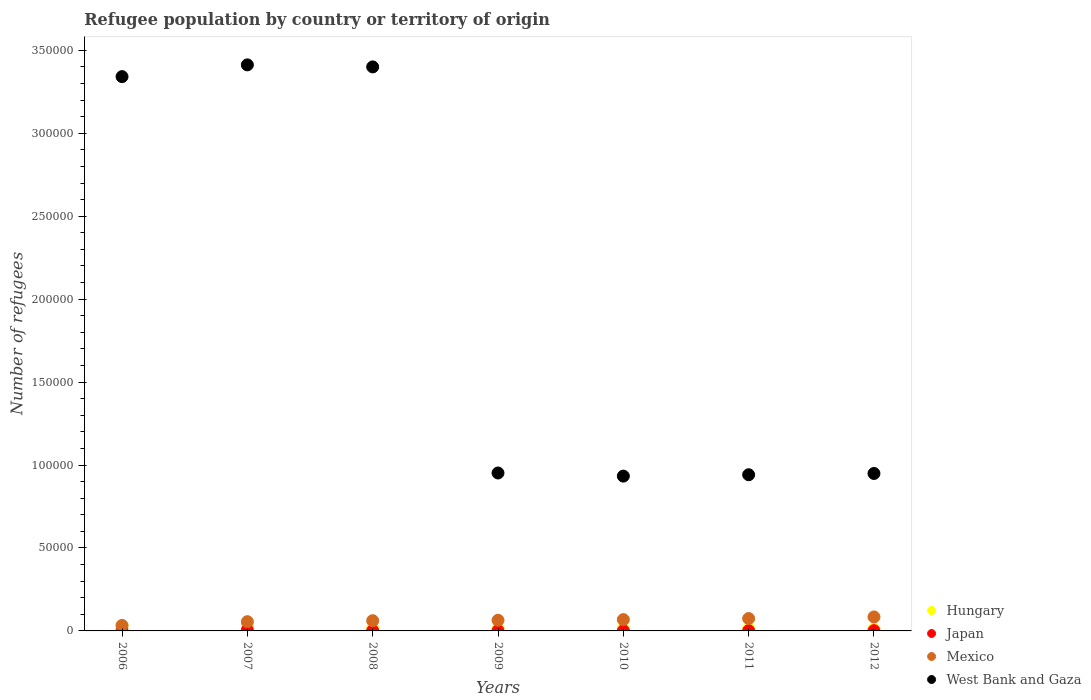How many different coloured dotlines are there?
Your answer should be compact. 4. What is the number of refugees in Japan in 2006?
Provide a short and direct response. 168. Across all years, what is the maximum number of refugees in Hungary?
Give a very brief answer. 3386. Across all years, what is the minimum number of refugees in Hungary?
Keep it short and to the point. 1087. In which year was the number of refugees in Hungary maximum?
Your answer should be compact. 2007. What is the total number of refugees in Hungary in the graph?
Ensure brevity in your answer.  1.34e+04. What is the difference between the number of refugees in West Bank and Gaza in 2007 and that in 2011?
Your answer should be compact. 2.47e+05. What is the difference between the number of refugees in West Bank and Gaza in 2008 and the number of refugees in Japan in 2009?
Your response must be concise. 3.40e+05. What is the average number of refugees in Mexico per year?
Provide a short and direct response. 6313.71. In the year 2009, what is the difference between the number of refugees in Japan and number of refugees in Hungary?
Provide a short and direct response. -1387. What is the ratio of the number of refugees in Mexico in 2009 to that in 2011?
Give a very brief answer. 0.86. Is the number of refugees in Hungary in 2006 less than that in 2009?
Make the answer very short. No. Is the difference between the number of refugees in Japan in 2007 and 2011 greater than the difference between the number of refugees in Hungary in 2007 and 2011?
Provide a short and direct response. No. What is the difference between the highest and the second highest number of refugees in Hungary?
Make the answer very short. 268. What is the difference between the highest and the lowest number of refugees in Japan?
Keep it short and to the point. 371. In how many years, is the number of refugees in Japan greater than the average number of refugees in Japan taken over all years?
Ensure brevity in your answer.  1. Is it the case that in every year, the sum of the number of refugees in Mexico and number of refugees in Japan  is greater than the sum of number of refugees in Hungary and number of refugees in West Bank and Gaza?
Ensure brevity in your answer.  No. Does the number of refugees in West Bank and Gaza monotonically increase over the years?
Provide a succinct answer. No. Is the number of refugees in Hungary strictly greater than the number of refugees in Mexico over the years?
Your answer should be compact. No. How many years are there in the graph?
Your answer should be very brief. 7. What is the difference between two consecutive major ticks on the Y-axis?
Offer a terse response. 5.00e+04. Are the values on the major ticks of Y-axis written in scientific E-notation?
Your answer should be very brief. No. Does the graph contain grids?
Keep it short and to the point. No. Where does the legend appear in the graph?
Offer a very short reply. Bottom right. How many legend labels are there?
Your answer should be very brief. 4. How are the legend labels stacked?
Keep it short and to the point. Vertical. What is the title of the graph?
Your response must be concise. Refugee population by country or territory of origin. Does "Nigeria" appear as one of the legend labels in the graph?
Keep it short and to the point. No. What is the label or title of the X-axis?
Your response must be concise. Years. What is the label or title of the Y-axis?
Offer a terse response. Number of refugees. What is the Number of refugees of Hungary in 2006?
Your response must be concise. 3118. What is the Number of refugees of Japan in 2006?
Your response must be concise. 168. What is the Number of refugees in Mexico in 2006?
Ensure brevity in your answer.  3304. What is the Number of refugees of West Bank and Gaza in 2006?
Your answer should be compact. 3.34e+05. What is the Number of refugees in Hungary in 2007?
Keep it short and to the point. 3386. What is the Number of refugees in Japan in 2007?
Ensure brevity in your answer.  521. What is the Number of refugees of Mexico in 2007?
Offer a very short reply. 5572. What is the Number of refugees of West Bank and Gaza in 2007?
Provide a succinct answer. 3.41e+05. What is the Number of refugees of Hungary in 2008?
Offer a very short reply. 1614. What is the Number of refugees of Japan in 2008?
Your response must be concise. 185. What is the Number of refugees in Mexico in 2008?
Provide a short and direct response. 6162. What is the Number of refugees in West Bank and Gaza in 2008?
Provide a short and direct response. 3.40e+05. What is the Number of refugees of Hungary in 2009?
Your answer should be compact. 1537. What is the Number of refugees of Japan in 2009?
Keep it short and to the point. 150. What is the Number of refugees in Mexico in 2009?
Your answer should be very brief. 6435. What is the Number of refugees in West Bank and Gaza in 2009?
Make the answer very short. 9.52e+04. What is the Number of refugees in Hungary in 2010?
Give a very brief answer. 1438. What is the Number of refugees in Japan in 2010?
Your answer should be compact. 152. What is the Number of refugees in Mexico in 2010?
Provide a short and direct response. 6816. What is the Number of refugees in West Bank and Gaza in 2010?
Ensure brevity in your answer.  9.33e+04. What is the Number of refugees in Hungary in 2011?
Give a very brief answer. 1238. What is the Number of refugees of Japan in 2011?
Ensure brevity in your answer.  176. What is the Number of refugees of Mexico in 2011?
Make the answer very short. 7472. What is the Number of refugees in West Bank and Gaza in 2011?
Your response must be concise. 9.42e+04. What is the Number of refugees of Hungary in 2012?
Your answer should be very brief. 1087. What is the Number of refugees in Japan in 2012?
Your response must be concise. 172. What is the Number of refugees in Mexico in 2012?
Offer a very short reply. 8435. What is the Number of refugees in West Bank and Gaza in 2012?
Your answer should be very brief. 9.49e+04. Across all years, what is the maximum Number of refugees in Hungary?
Give a very brief answer. 3386. Across all years, what is the maximum Number of refugees in Japan?
Offer a very short reply. 521. Across all years, what is the maximum Number of refugees in Mexico?
Provide a short and direct response. 8435. Across all years, what is the maximum Number of refugees in West Bank and Gaza?
Offer a very short reply. 3.41e+05. Across all years, what is the minimum Number of refugees in Hungary?
Your response must be concise. 1087. Across all years, what is the minimum Number of refugees in Japan?
Provide a succinct answer. 150. Across all years, what is the minimum Number of refugees of Mexico?
Offer a very short reply. 3304. Across all years, what is the minimum Number of refugees of West Bank and Gaza?
Provide a short and direct response. 9.33e+04. What is the total Number of refugees of Hungary in the graph?
Make the answer very short. 1.34e+04. What is the total Number of refugees of Japan in the graph?
Offer a terse response. 1524. What is the total Number of refugees in Mexico in the graph?
Give a very brief answer. 4.42e+04. What is the total Number of refugees in West Bank and Gaza in the graph?
Give a very brief answer. 1.39e+06. What is the difference between the Number of refugees of Hungary in 2006 and that in 2007?
Your response must be concise. -268. What is the difference between the Number of refugees of Japan in 2006 and that in 2007?
Keep it short and to the point. -353. What is the difference between the Number of refugees in Mexico in 2006 and that in 2007?
Your answer should be very brief. -2268. What is the difference between the Number of refugees in West Bank and Gaza in 2006 and that in 2007?
Provide a short and direct response. -7095. What is the difference between the Number of refugees in Hungary in 2006 and that in 2008?
Give a very brief answer. 1504. What is the difference between the Number of refugees of Mexico in 2006 and that in 2008?
Keep it short and to the point. -2858. What is the difference between the Number of refugees in West Bank and Gaza in 2006 and that in 2008?
Your answer should be very brief. -5874. What is the difference between the Number of refugees of Hungary in 2006 and that in 2009?
Provide a succinct answer. 1581. What is the difference between the Number of refugees of Mexico in 2006 and that in 2009?
Your response must be concise. -3131. What is the difference between the Number of refugees in West Bank and Gaza in 2006 and that in 2009?
Your answer should be very brief. 2.39e+05. What is the difference between the Number of refugees of Hungary in 2006 and that in 2010?
Make the answer very short. 1680. What is the difference between the Number of refugees of Mexico in 2006 and that in 2010?
Ensure brevity in your answer.  -3512. What is the difference between the Number of refugees of West Bank and Gaza in 2006 and that in 2010?
Make the answer very short. 2.41e+05. What is the difference between the Number of refugees in Hungary in 2006 and that in 2011?
Ensure brevity in your answer.  1880. What is the difference between the Number of refugees of Japan in 2006 and that in 2011?
Your answer should be compact. -8. What is the difference between the Number of refugees of Mexico in 2006 and that in 2011?
Your answer should be compact. -4168. What is the difference between the Number of refugees in West Bank and Gaza in 2006 and that in 2011?
Provide a short and direct response. 2.40e+05. What is the difference between the Number of refugees in Hungary in 2006 and that in 2012?
Provide a short and direct response. 2031. What is the difference between the Number of refugees in Japan in 2006 and that in 2012?
Your response must be concise. -4. What is the difference between the Number of refugees in Mexico in 2006 and that in 2012?
Ensure brevity in your answer.  -5131. What is the difference between the Number of refugees in West Bank and Gaza in 2006 and that in 2012?
Give a very brief answer. 2.39e+05. What is the difference between the Number of refugees of Hungary in 2007 and that in 2008?
Your answer should be very brief. 1772. What is the difference between the Number of refugees in Japan in 2007 and that in 2008?
Offer a very short reply. 336. What is the difference between the Number of refugees in Mexico in 2007 and that in 2008?
Your answer should be compact. -590. What is the difference between the Number of refugees in West Bank and Gaza in 2007 and that in 2008?
Make the answer very short. 1221. What is the difference between the Number of refugees in Hungary in 2007 and that in 2009?
Provide a short and direct response. 1849. What is the difference between the Number of refugees of Japan in 2007 and that in 2009?
Your answer should be very brief. 371. What is the difference between the Number of refugees of Mexico in 2007 and that in 2009?
Your answer should be very brief. -863. What is the difference between the Number of refugees in West Bank and Gaza in 2007 and that in 2009?
Provide a short and direct response. 2.46e+05. What is the difference between the Number of refugees in Hungary in 2007 and that in 2010?
Keep it short and to the point. 1948. What is the difference between the Number of refugees of Japan in 2007 and that in 2010?
Provide a succinct answer. 369. What is the difference between the Number of refugees in Mexico in 2007 and that in 2010?
Ensure brevity in your answer.  -1244. What is the difference between the Number of refugees of West Bank and Gaza in 2007 and that in 2010?
Your answer should be compact. 2.48e+05. What is the difference between the Number of refugees in Hungary in 2007 and that in 2011?
Provide a short and direct response. 2148. What is the difference between the Number of refugees in Japan in 2007 and that in 2011?
Provide a succinct answer. 345. What is the difference between the Number of refugees of Mexico in 2007 and that in 2011?
Your answer should be very brief. -1900. What is the difference between the Number of refugees in West Bank and Gaza in 2007 and that in 2011?
Provide a succinct answer. 2.47e+05. What is the difference between the Number of refugees of Hungary in 2007 and that in 2012?
Your response must be concise. 2299. What is the difference between the Number of refugees of Japan in 2007 and that in 2012?
Ensure brevity in your answer.  349. What is the difference between the Number of refugees of Mexico in 2007 and that in 2012?
Offer a terse response. -2863. What is the difference between the Number of refugees in West Bank and Gaza in 2007 and that in 2012?
Your answer should be compact. 2.46e+05. What is the difference between the Number of refugees of Hungary in 2008 and that in 2009?
Provide a succinct answer. 77. What is the difference between the Number of refugees in Japan in 2008 and that in 2009?
Offer a terse response. 35. What is the difference between the Number of refugees of Mexico in 2008 and that in 2009?
Provide a succinct answer. -273. What is the difference between the Number of refugees of West Bank and Gaza in 2008 and that in 2009?
Make the answer very short. 2.45e+05. What is the difference between the Number of refugees of Hungary in 2008 and that in 2010?
Provide a succinct answer. 176. What is the difference between the Number of refugees in Japan in 2008 and that in 2010?
Your answer should be compact. 33. What is the difference between the Number of refugees in Mexico in 2008 and that in 2010?
Make the answer very short. -654. What is the difference between the Number of refugees in West Bank and Gaza in 2008 and that in 2010?
Ensure brevity in your answer.  2.47e+05. What is the difference between the Number of refugees of Hungary in 2008 and that in 2011?
Provide a short and direct response. 376. What is the difference between the Number of refugees of Mexico in 2008 and that in 2011?
Provide a succinct answer. -1310. What is the difference between the Number of refugees in West Bank and Gaza in 2008 and that in 2011?
Give a very brief answer. 2.46e+05. What is the difference between the Number of refugees in Hungary in 2008 and that in 2012?
Keep it short and to the point. 527. What is the difference between the Number of refugees in Japan in 2008 and that in 2012?
Keep it short and to the point. 13. What is the difference between the Number of refugees in Mexico in 2008 and that in 2012?
Make the answer very short. -2273. What is the difference between the Number of refugees in West Bank and Gaza in 2008 and that in 2012?
Your answer should be very brief. 2.45e+05. What is the difference between the Number of refugees in Hungary in 2009 and that in 2010?
Your response must be concise. 99. What is the difference between the Number of refugees in Mexico in 2009 and that in 2010?
Your response must be concise. -381. What is the difference between the Number of refugees of West Bank and Gaza in 2009 and that in 2010?
Make the answer very short. 1878. What is the difference between the Number of refugees in Hungary in 2009 and that in 2011?
Keep it short and to the point. 299. What is the difference between the Number of refugees in Mexico in 2009 and that in 2011?
Offer a terse response. -1037. What is the difference between the Number of refugees in West Bank and Gaza in 2009 and that in 2011?
Give a very brief answer. 1051. What is the difference between the Number of refugees of Hungary in 2009 and that in 2012?
Provide a succinct answer. 450. What is the difference between the Number of refugees in Japan in 2009 and that in 2012?
Your answer should be compact. -22. What is the difference between the Number of refugees in Mexico in 2009 and that in 2012?
Provide a short and direct response. -2000. What is the difference between the Number of refugees of West Bank and Gaza in 2009 and that in 2012?
Provide a succinct answer. 283. What is the difference between the Number of refugees of Mexico in 2010 and that in 2011?
Make the answer very short. -656. What is the difference between the Number of refugees in West Bank and Gaza in 2010 and that in 2011?
Give a very brief answer. -827. What is the difference between the Number of refugees of Hungary in 2010 and that in 2012?
Offer a very short reply. 351. What is the difference between the Number of refugees of Mexico in 2010 and that in 2012?
Your response must be concise. -1619. What is the difference between the Number of refugees of West Bank and Gaza in 2010 and that in 2012?
Offer a very short reply. -1595. What is the difference between the Number of refugees of Hungary in 2011 and that in 2012?
Keep it short and to the point. 151. What is the difference between the Number of refugees in Japan in 2011 and that in 2012?
Offer a very short reply. 4. What is the difference between the Number of refugees in Mexico in 2011 and that in 2012?
Keep it short and to the point. -963. What is the difference between the Number of refugees of West Bank and Gaza in 2011 and that in 2012?
Your answer should be very brief. -768. What is the difference between the Number of refugees of Hungary in 2006 and the Number of refugees of Japan in 2007?
Your answer should be very brief. 2597. What is the difference between the Number of refugees in Hungary in 2006 and the Number of refugees in Mexico in 2007?
Make the answer very short. -2454. What is the difference between the Number of refugees in Hungary in 2006 and the Number of refugees in West Bank and Gaza in 2007?
Offer a very short reply. -3.38e+05. What is the difference between the Number of refugees in Japan in 2006 and the Number of refugees in Mexico in 2007?
Provide a succinct answer. -5404. What is the difference between the Number of refugees in Japan in 2006 and the Number of refugees in West Bank and Gaza in 2007?
Your answer should be compact. -3.41e+05. What is the difference between the Number of refugees of Mexico in 2006 and the Number of refugees of West Bank and Gaza in 2007?
Provide a succinct answer. -3.38e+05. What is the difference between the Number of refugees in Hungary in 2006 and the Number of refugees in Japan in 2008?
Provide a short and direct response. 2933. What is the difference between the Number of refugees of Hungary in 2006 and the Number of refugees of Mexico in 2008?
Your response must be concise. -3044. What is the difference between the Number of refugees of Hungary in 2006 and the Number of refugees of West Bank and Gaza in 2008?
Ensure brevity in your answer.  -3.37e+05. What is the difference between the Number of refugees of Japan in 2006 and the Number of refugees of Mexico in 2008?
Ensure brevity in your answer.  -5994. What is the difference between the Number of refugees in Japan in 2006 and the Number of refugees in West Bank and Gaza in 2008?
Your answer should be very brief. -3.40e+05. What is the difference between the Number of refugees of Mexico in 2006 and the Number of refugees of West Bank and Gaza in 2008?
Offer a very short reply. -3.37e+05. What is the difference between the Number of refugees in Hungary in 2006 and the Number of refugees in Japan in 2009?
Offer a terse response. 2968. What is the difference between the Number of refugees of Hungary in 2006 and the Number of refugees of Mexico in 2009?
Offer a very short reply. -3317. What is the difference between the Number of refugees of Hungary in 2006 and the Number of refugees of West Bank and Gaza in 2009?
Offer a very short reply. -9.21e+04. What is the difference between the Number of refugees of Japan in 2006 and the Number of refugees of Mexico in 2009?
Your response must be concise. -6267. What is the difference between the Number of refugees in Japan in 2006 and the Number of refugees in West Bank and Gaza in 2009?
Offer a very short reply. -9.50e+04. What is the difference between the Number of refugees of Mexico in 2006 and the Number of refugees of West Bank and Gaza in 2009?
Make the answer very short. -9.19e+04. What is the difference between the Number of refugees of Hungary in 2006 and the Number of refugees of Japan in 2010?
Ensure brevity in your answer.  2966. What is the difference between the Number of refugees in Hungary in 2006 and the Number of refugees in Mexico in 2010?
Keep it short and to the point. -3698. What is the difference between the Number of refugees in Hungary in 2006 and the Number of refugees in West Bank and Gaza in 2010?
Provide a succinct answer. -9.02e+04. What is the difference between the Number of refugees in Japan in 2006 and the Number of refugees in Mexico in 2010?
Your answer should be compact. -6648. What is the difference between the Number of refugees of Japan in 2006 and the Number of refugees of West Bank and Gaza in 2010?
Give a very brief answer. -9.32e+04. What is the difference between the Number of refugees of Mexico in 2006 and the Number of refugees of West Bank and Gaza in 2010?
Provide a short and direct response. -9.00e+04. What is the difference between the Number of refugees in Hungary in 2006 and the Number of refugees in Japan in 2011?
Ensure brevity in your answer.  2942. What is the difference between the Number of refugees of Hungary in 2006 and the Number of refugees of Mexico in 2011?
Ensure brevity in your answer.  -4354. What is the difference between the Number of refugees of Hungary in 2006 and the Number of refugees of West Bank and Gaza in 2011?
Ensure brevity in your answer.  -9.10e+04. What is the difference between the Number of refugees of Japan in 2006 and the Number of refugees of Mexico in 2011?
Offer a terse response. -7304. What is the difference between the Number of refugees in Japan in 2006 and the Number of refugees in West Bank and Gaza in 2011?
Keep it short and to the point. -9.40e+04. What is the difference between the Number of refugees in Mexico in 2006 and the Number of refugees in West Bank and Gaza in 2011?
Provide a succinct answer. -9.08e+04. What is the difference between the Number of refugees of Hungary in 2006 and the Number of refugees of Japan in 2012?
Your response must be concise. 2946. What is the difference between the Number of refugees of Hungary in 2006 and the Number of refugees of Mexico in 2012?
Ensure brevity in your answer.  -5317. What is the difference between the Number of refugees in Hungary in 2006 and the Number of refugees in West Bank and Gaza in 2012?
Make the answer very short. -9.18e+04. What is the difference between the Number of refugees of Japan in 2006 and the Number of refugees of Mexico in 2012?
Provide a short and direct response. -8267. What is the difference between the Number of refugees in Japan in 2006 and the Number of refugees in West Bank and Gaza in 2012?
Ensure brevity in your answer.  -9.48e+04. What is the difference between the Number of refugees in Mexico in 2006 and the Number of refugees in West Bank and Gaza in 2012?
Offer a terse response. -9.16e+04. What is the difference between the Number of refugees of Hungary in 2007 and the Number of refugees of Japan in 2008?
Make the answer very short. 3201. What is the difference between the Number of refugees of Hungary in 2007 and the Number of refugees of Mexico in 2008?
Make the answer very short. -2776. What is the difference between the Number of refugees of Hungary in 2007 and the Number of refugees of West Bank and Gaza in 2008?
Keep it short and to the point. -3.37e+05. What is the difference between the Number of refugees in Japan in 2007 and the Number of refugees in Mexico in 2008?
Your answer should be very brief. -5641. What is the difference between the Number of refugees in Japan in 2007 and the Number of refugees in West Bank and Gaza in 2008?
Your answer should be compact. -3.39e+05. What is the difference between the Number of refugees of Mexico in 2007 and the Number of refugees of West Bank and Gaza in 2008?
Ensure brevity in your answer.  -3.34e+05. What is the difference between the Number of refugees of Hungary in 2007 and the Number of refugees of Japan in 2009?
Provide a short and direct response. 3236. What is the difference between the Number of refugees in Hungary in 2007 and the Number of refugees in Mexico in 2009?
Give a very brief answer. -3049. What is the difference between the Number of refugees in Hungary in 2007 and the Number of refugees in West Bank and Gaza in 2009?
Make the answer very short. -9.18e+04. What is the difference between the Number of refugees of Japan in 2007 and the Number of refugees of Mexico in 2009?
Make the answer very short. -5914. What is the difference between the Number of refugees in Japan in 2007 and the Number of refugees in West Bank and Gaza in 2009?
Your answer should be very brief. -9.47e+04. What is the difference between the Number of refugees of Mexico in 2007 and the Number of refugees of West Bank and Gaza in 2009?
Keep it short and to the point. -8.96e+04. What is the difference between the Number of refugees in Hungary in 2007 and the Number of refugees in Japan in 2010?
Give a very brief answer. 3234. What is the difference between the Number of refugees in Hungary in 2007 and the Number of refugees in Mexico in 2010?
Your answer should be very brief. -3430. What is the difference between the Number of refugees of Hungary in 2007 and the Number of refugees of West Bank and Gaza in 2010?
Give a very brief answer. -8.99e+04. What is the difference between the Number of refugees of Japan in 2007 and the Number of refugees of Mexico in 2010?
Your answer should be compact. -6295. What is the difference between the Number of refugees of Japan in 2007 and the Number of refugees of West Bank and Gaza in 2010?
Give a very brief answer. -9.28e+04. What is the difference between the Number of refugees of Mexico in 2007 and the Number of refugees of West Bank and Gaza in 2010?
Make the answer very short. -8.78e+04. What is the difference between the Number of refugees of Hungary in 2007 and the Number of refugees of Japan in 2011?
Provide a short and direct response. 3210. What is the difference between the Number of refugees in Hungary in 2007 and the Number of refugees in Mexico in 2011?
Provide a short and direct response. -4086. What is the difference between the Number of refugees of Hungary in 2007 and the Number of refugees of West Bank and Gaza in 2011?
Ensure brevity in your answer.  -9.08e+04. What is the difference between the Number of refugees of Japan in 2007 and the Number of refugees of Mexico in 2011?
Your response must be concise. -6951. What is the difference between the Number of refugees in Japan in 2007 and the Number of refugees in West Bank and Gaza in 2011?
Offer a terse response. -9.36e+04. What is the difference between the Number of refugees in Mexico in 2007 and the Number of refugees in West Bank and Gaza in 2011?
Your response must be concise. -8.86e+04. What is the difference between the Number of refugees of Hungary in 2007 and the Number of refugees of Japan in 2012?
Offer a terse response. 3214. What is the difference between the Number of refugees in Hungary in 2007 and the Number of refugees in Mexico in 2012?
Your answer should be very brief. -5049. What is the difference between the Number of refugees of Hungary in 2007 and the Number of refugees of West Bank and Gaza in 2012?
Offer a very short reply. -9.15e+04. What is the difference between the Number of refugees of Japan in 2007 and the Number of refugees of Mexico in 2012?
Provide a succinct answer. -7914. What is the difference between the Number of refugees of Japan in 2007 and the Number of refugees of West Bank and Gaza in 2012?
Your response must be concise. -9.44e+04. What is the difference between the Number of refugees in Mexico in 2007 and the Number of refugees in West Bank and Gaza in 2012?
Your answer should be very brief. -8.93e+04. What is the difference between the Number of refugees in Hungary in 2008 and the Number of refugees in Japan in 2009?
Your answer should be compact. 1464. What is the difference between the Number of refugees in Hungary in 2008 and the Number of refugees in Mexico in 2009?
Your response must be concise. -4821. What is the difference between the Number of refugees of Hungary in 2008 and the Number of refugees of West Bank and Gaza in 2009?
Your response must be concise. -9.36e+04. What is the difference between the Number of refugees of Japan in 2008 and the Number of refugees of Mexico in 2009?
Provide a short and direct response. -6250. What is the difference between the Number of refugees of Japan in 2008 and the Number of refugees of West Bank and Gaza in 2009?
Ensure brevity in your answer.  -9.50e+04. What is the difference between the Number of refugees in Mexico in 2008 and the Number of refugees in West Bank and Gaza in 2009?
Offer a very short reply. -8.90e+04. What is the difference between the Number of refugees of Hungary in 2008 and the Number of refugees of Japan in 2010?
Keep it short and to the point. 1462. What is the difference between the Number of refugees of Hungary in 2008 and the Number of refugees of Mexico in 2010?
Keep it short and to the point. -5202. What is the difference between the Number of refugees of Hungary in 2008 and the Number of refugees of West Bank and Gaza in 2010?
Offer a very short reply. -9.17e+04. What is the difference between the Number of refugees in Japan in 2008 and the Number of refugees in Mexico in 2010?
Ensure brevity in your answer.  -6631. What is the difference between the Number of refugees in Japan in 2008 and the Number of refugees in West Bank and Gaza in 2010?
Ensure brevity in your answer.  -9.31e+04. What is the difference between the Number of refugees of Mexico in 2008 and the Number of refugees of West Bank and Gaza in 2010?
Your answer should be compact. -8.72e+04. What is the difference between the Number of refugees in Hungary in 2008 and the Number of refugees in Japan in 2011?
Make the answer very short. 1438. What is the difference between the Number of refugees in Hungary in 2008 and the Number of refugees in Mexico in 2011?
Give a very brief answer. -5858. What is the difference between the Number of refugees in Hungary in 2008 and the Number of refugees in West Bank and Gaza in 2011?
Keep it short and to the point. -9.25e+04. What is the difference between the Number of refugees of Japan in 2008 and the Number of refugees of Mexico in 2011?
Your answer should be very brief. -7287. What is the difference between the Number of refugees of Japan in 2008 and the Number of refugees of West Bank and Gaza in 2011?
Give a very brief answer. -9.40e+04. What is the difference between the Number of refugees in Mexico in 2008 and the Number of refugees in West Bank and Gaza in 2011?
Offer a very short reply. -8.80e+04. What is the difference between the Number of refugees of Hungary in 2008 and the Number of refugees of Japan in 2012?
Your answer should be very brief. 1442. What is the difference between the Number of refugees of Hungary in 2008 and the Number of refugees of Mexico in 2012?
Provide a succinct answer. -6821. What is the difference between the Number of refugees in Hungary in 2008 and the Number of refugees in West Bank and Gaza in 2012?
Your answer should be compact. -9.33e+04. What is the difference between the Number of refugees in Japan in 2008 and the Number of refugees in Mexico in 2012?
Offer a very short reply. -8250. What is the difference between the Number of refugees in Japan in 2008 and the Number of refugees in West Bank and Gaza in 2012?
Keep it short and to the point. -9.47e+04. What is the difference between the Number of refugees of Mexico in 2008 and the Number of refugees of West Bank and Gaza in 2012?
Your response must be concise. -8.88e+04. What is the difference between the Number of refugees of Hungary in 2009 and the Number of refugees of Japan in 2010?
Give a very brief answer. 1385. What is the difference between the Number of refugees in Hungary in 2009 and the Number of refugees in Mexico in 2010?
Make the answer very short. -5279. What is the difference between the Number of refugees in Hungary in 2009 and the Number of refugees in West Bank and Gaza in 2010?
Offer a terse response. -9.18e+04. What is the difference between the Number of refugees of Japan in 2009 and the Number of refugees of Mexico in 2010?
Make the answer very short. -6666. What is the difference between the Number of refugees of Japan in 2009 and the Number of refugees of West Bank and Gaza in 2010?
Your response must be concise. -9.32e+04. What is the difference between the Number of refugees in Mexico in 2009 and the Number of refugees in West Bank and Gaza in 2010?
Your answer should be very brief. -8.69e+04. What is the difference between the Number of refugees in Hungary in 2009 and the Number of refugees in Japan in 2011?
Ensure brevity in your answer.  1361. What is the difference between the Number of refugees of Hungary in 2009 and the Number of refugees of Mexico in 2011?
Your answer should be compact. -5935. What is the difference between the Number of refugees of Hungary in 2009 and the Number of refugees of West Bank and Gaza in 2011?
Provide a short and direct response. -9.26e+04. What is the difference between the Number of refugees in Japan in 2009 and the Number of refugees in Mexico in 2011?
Provide a short and direct response. -7322. What is the difference between the Number of refugees of Japan in 2009 and the Number of refugees of West Bank and Gaza in 2011?
Your response must be concise. -9.40e+04. What is the difference between the Number of refugees in Mexico in 2009 and the Number of refugees in West Bank and Gaza in 2011?
Provide a succinct answer. -8.77e+04. What is the difference between the Number of refugees in Hungary in 2009 and the Number of refugees in Japan in 2012?
Ensure brevity in your answer.  1365. What is the difference between the Number of refugees of Hungary in 2009 and the Number of refugees of Mexico in 2012?
Ensure brevity in your answer.  -6898. What is the difference between the Number of refugees of Hungary in 2009 and the Number of refugees of West Bank and Gaza in 2012?
Offer a very short reply. -9.34e+04. What is the difference between the Number of refugees in Japan in 2009 and the Number of refugees in Mexico in 2012?
Give a very brief answer. -8285. What is the difference between the Number of refugees of Japan in 2009 and the Number of refugees of West Bank and Gaza in 2012?
Your answer should be compact. -9.48e+04. What is the difference between the Number of refugees of Mexico in 2009 and the Number of refugees of West Bank and Gaza in 2012?
Offer a very short reply. -8.85e+04. What is the difference between the Number of refugees in Hungary in 2010 and the Number of refugees in Japan in 2011?
Provide a short and direct response. 1262. What is the difference between the Number of refugees in Hungary in 2010 and the Number of refugees in Mexico in 2011?
Provide a short and direct response. -6034. What is the difference between the Number of refugees of Hungary in 2010 and the Number of refugees of West Bank and Gaza in 2011?
Your answer should be very brief. -9.27e+04. What is the difference between the Number of refugees of Japan in 2010 and the Number of refugees of Mexico in 2011?
Give a very brief answer. -7320. What is the difference between the Number of refugees in Japan in 2010 and the Number of refugees in West Bank and Gaza in 2011?
Offer a terse response. -9.40e+04. What is the difference between the Number of refugees in Mexico in 2010 and the Number of refugees in West Bank and Gaza in 2011?
Your answer should be compact. -8.73e+04. What is the difference between the Number of refugees in Hungary in 2010 and the Number of refugees in Japan in 2012?
Offer a terse response. 1266. What is the difference between the Number of refugees in Hungary in 2010 and the Number of refugees in Mexico in 2012?
Your answer should be compact. -6997. What is the difference between the Number of refugees of Hungary in 2010 and the Number of refugees of West Bank and Gaza in 2012?
Offer a very short reply. -9.35e+04. What is the difference between the Number of refugees of Japan in 2010 and the Number of refugees of Mexico in 2012?
Give a very brief answer. -8283. What is the difference between the Number of refugees of Japan in 2010 and the Number of refugees of West Bank and Gaza in 2012?
Your answer should be very brief. -9.48e+04. What is the difference between the Number of refugees of Mexico in 2010 and the Number of refugees of West Bank and Gaza in 2012?
Your answer should be compact. -8.81e+04. What is the difference between the Number of refugees in Hungary in 2011 and the Number of refugees in Japan in 2012?
Make the answer very short. 1066. What is the difference between the Number of refugees of Hungary in 2011 and the Number of refugees of Mexico in 2012?
Provide a succinct answer. -7197. What is the difference between the Number of refugees of Hungary in 2011 and the Number of refugees of West Bank and Gaza in 2012?
Offer a terse response. -9.37e+04. What is the difference between the Number of refugees of Japan in 2011 and the Number of refugees of Mexico in 2012?
Your answer should be very brief. -8259. What is the difference between the Number of refugees in Japan in 2011 and the Number of refugees in West Bank and Gaza in 2012?
Ensure brevity in your answer.  -9.47e+04. What is the difference between the Number of refugees in Mexico in 2011 and the Number of refugees in West Bank and Gaza in 2012?
Keep it short and to the point. -8.74e+04. What is the average Number of refugees in Hungary per year?
Offer a terse response. 1916.86. What is the average Number of refugees of Japan per year?
Provide a short and direct response. 217.71. What is the average Number of refugees of Mexico per year?
Give a very brief answer. 6313.71. What is the average Number of refugees of West Bank and Gaza per year?
Your answer should be very brief. 1.99e+05. In the year 2006, what is the difference between the Number of refugees of Hungary and Number of refugees of Japan?
Make the answer very short. 2950. In the year 2006, what is the difference between the Number of refugees of Hungary and Number of refugees of Mexico?
Provide a succinct answer. -186. In the year 2006, what is the difference between the Number of refugees in Hungary and Number of refugees in West Bank and Gaza?
Make the answer very short. -3.31e+05. In the year 2006, what is the difference between the Number of refugees of Japan and Number of refugees of Mexico?
Offer a very short reply. -3136. In the year 2006, what is the difference between the Number of refugees of Japan and Number of refugees of West Bank and Gaza?
Your answer should be compact. -3.34e+05. In the year 2006, what is the difference between the Number of refugees of Mexico and Number of refugees of West Bank and Gaza?
Your response must be concise. -3.31e+05. In the year 2007, what is the difference between the Number of refugees in Hungary and Number of refugees in Japan?
Make the answer very short. 2865. In the year 2007, what is the difference between the Number of refugees of Hungary and Number of refugees of Mexico?
Provide a short and direct response. -2186. In the year 2007, what is the difference between the Number of refugees in Hungary and Number of refugees in West Bank and Gaza?
Provide a short and direct response. -3.38e+05. In the year 2007, what is the difference between the Number of refugees in Japan and Number of refugees in Mexico?
Your response must be concise. -5051. In the year 2007, what is the difference between the Number of refugees in Japan and Number of refugees in West Bank and Gaza?
Offer a very short reply. -3.41e+05. In the year 2007, what is the difference between the Number of refugees in Mexico and Number of refugees in West Bank and Gaza?
Provide a short and direct response. -3.36e+05. In the year 2008, what is the difference between the Number of refugees of Hungary and Number of refugees of Japan?
Provide a short and direct response. 1429. In the year 2008, what is the difference between the Number of refugees of Hungary and Number of refugees of Mexico?
Give a very brief answer. -4548. In the year 2008, what is the difference between the Number of refugees in Hungary and Number of refugees in West Bank and Gaza?
Make the answer very short. -3.38e+05. In the year 2008, what is the difference between the Number of refugees in Japan and Number of refugees in Mexico?
Offer a very short reply. -5977. In the year 2008, what is the difference between the Number of refugees of Japan and Number of refugees of West Bank and Gaza?
Offer a terse response. -3.40e+05. In the year 2008, what is the difference between the Number of refugees in Mexico and Number of refugees in West Bank and Gaza?
Provide a succinct answer. -3.34e+05. In the year 2009, what is the difference between the Number of refugees of Hungary and Number of refugees of Japan?
Make the answer very short. 1387. In the year 2009, what is the difference between the Number of refugees of Hungary and Number of refugees of Mexico?
Your answer should be compact. -4898. In the year 2009, what is the difference between the Number of refugees in Hungary and Number of refugees in West Bank and Gaza?
Your response must be concise. -9.37e+04. In the year 2009, what is the difference between the Number of refugees of Japan and Number of refugees of Mexico?
Offer a terse response. -6285. In the year 2009, what is the difference between the Number of refugees in Japan and Number of refugees in West Bank and Gaza?
Make the answer very short. -9.51e+04. In the year 2009, what is the difference between the Number of refugees of Mexico and Number of refugees of West Bank and Gaza?
Your answer should be very brief. -8.88e+04. In the year 2010, what is the difference between the Number of refugees in Hungary and Number of refugees in Japan?
Your answer should be compact. 1286. In the year 2010, what is the difference between the Number of refugees of Hungary and Number of refugees of Mexico?
Give a very brief answer. -5378. In the year 2010, what is the difference between the Number of refugees of Hungary and Number of refugees of West Bank and Gaza?
Provide a succinct answer. -9.19e+04. In the year 2010, what is the difference between the Number of refugees in Japan and Number of refugees in Mexico?
Ensure brevity in your answer.  -6664. In the year 2010, what is the difference between the Number of refugees of Japan and Number of refugees of West Bank and Gaza?
Offer a very short reply. -9.32e+04. In the year 2010, what is the difference between the Number of refugees in Mexico and Number of refugees in West Bank and Gaza?
Provide a short and direct response. -8.65e+04. In the year 2011, what is the difference between the Number of refugees in Hungary and Number of refugees in Japan?
Provide a short and direct response. 1062. In the year 2011, what is the difference between the Number of refugees in Hungary and Number of refugees in Mexico?
Ensure brevity in your answer.  -6234. In the year 2011, what is the difference between the Number of refugees of Hungary and Number of refugees of West Bank and Gaza?
Keep it short and to the point. -9.29e+04. In the year 2011, what is the difference between the Number of refugees of Japan and Number of refugees of Mexico?
Your response must be concise. -7296. In the year 2011, what is the difference between the Number of refugees in Japan and Number of refugees in West Bank and Gaza?
Offer a terse response. -9.40e+04. In the year 2011, what is the difference between the Number of refugees of Mexico and Number of refugees of West Bank and Gaza?
Ensure brevity in your answer.  -8.67e+04. In the year 2012, what is the difference between the Number of refugees in Hungary and Number of refugees in Japan?
Ensure brevity in your answer.  915. In the year 2012, what is the difference between the Number of refugees of Hungary and Number of refugees of Mexico?
Your response must be concise. -7348. In the year 2012, what is the difference between the Number of refugees in Hungary and Number of refugees in West Bank and Gaza?
Make the answer very short. -9.38e+04. In the year 2012, what is the difference between the Number of refugees in Japan and Number of refugees in Mexico?
Your response must be concise. -8263. In the year 2012, what is the difference between the Number of refugees in Japan and Number of refugees in West Bank and Gaza?
Provide a succinct answer. -9.47e+04. In the year 2012, what is the difference between the Number of refugees of Mexico and Number of refugees of West Bank and Gaza?
Make the answer very short. -8.65e+04. What is the ratio of the Number of refugees of Hungary in 2006 to that in 2007?
Give a very brief answer. 0.92. What is the ratio of the Number of refugees in Japan in 2006 to that in 2007?
Give a very brief answer. 0.32. What is the ratio of the Number of refugees of Mexico in 2006 to that in 2007?
Give a very brief answer. 0.59. What is the ratio of the Number of refugees of West Bank and Gaza in 2006 to that in 2007?
Make the answer very short. 0.98. What is the ratio of the Number of refugees of Hungary in 2006 to that in 2008?
Provide a succinct answer. 1.93. What is the ratio of the Number of refugees in Japan in 2006 to that in 2008?
Provide a succinct answer. 0.91. What is the ratio of the Number of refugees in Mexico in 2006 to that in 2008?
Offer a very short reply. 0.54. What is the ratio of the Number of refugees of West Bank and Gaza in 2006 to that in 2008?
Keep it short and to the point. 0.98. What is the ratio of the Number of refugees in Hungary in 2006 to that in 2009?
Offer a very short reply. 2.03. What is the ratio of the Number of refugees of Japan in 2006 to that in 2009?
Your response must be concise. 1.12. What is the ratio of the Number of refugees of Mexico in 2006 to that in 2009?
Provide a short and direct response. 0.51. What is the ratio of the Number of refugees of West Bank and Gaza in 2006 to that in 2009?
Provide a succinct answer. 3.51. What is the ratio of the Number of refugees of Hungary in 2006 to that in 2010?
Your answer should be compact. 2.17. What is the ratio of the Number of refugees of Japan in 2006 to that in 2010?
Ensure brevity in your answer.  1.11. What is the ratio of the Number of refugees in Mexico in 2006 to that in 2010?
Provide a short and direct response. 0.48. What is the ratio of the Number of refugees of West Bank and Gaza in 2006 to that in 2010?
Make the answer very short. 3.58. What is the ratio of the Number of refugees of Hungary in 2006 to that in 2011?
Offer a terse response. 2.52. What is the ratio of the Number of refugees of Japan in 2006 to that in 2011?
Keep it short and to the point. 0.95. What is the ratio of the Number of refugees of Mexico in 2006 to that in 2011?
Provide a short and direct response. 0.44. What is the ratio of the Number of refugees of West Bank and Gaza in 2006 to that in 2011?
Make the answer very short. 3.55. What is the ratio of the Number of refugees of Hungary in 2006 to that in 2012?
Make the answer very short. 2.87. What is the ratio of the Number of refugees in Japan in 2006 to that in 2012?
Ensure brevity in your answer.  0.98. What is the ratio of the Number of refugees in Mexico in 2006 to that in 2012?
Your answer should be very brief. 0.39. What is the ratio of the Number of refugees in West Bank and Gaza in 2006 to that in 2012?
Provide a succinct answer. 3.52. What is the ratio of the Number of refugees in Hungary in 2007 to that in 2008?
Ensure brevity in your answer.  2.1. What is the ratio of the Number of refugees of Japan in 2007 to that in 2008?
Keep it short and to the point. 2.82. What is the ratio of the Number of refugees in Mexico in 2007 to that in 2008?
Make the answer very short. 0.9. What is the ratio of the Number of refugees in Hungary in 2007 to that in 2009?
Provide a succinct answer. 2.2. What is the ratio of the Number of refugees in Japan in 2007 to that in 2009?
Ensure brevity in your answer.  3.47. What is the ratio of the Number of refugees of Mexico in 2007 to that in 2009?
Your answer should be very brief. 0.87. What is the ratio of the Number of refugees in West Bank and Gaza in 2007 to that in 2009?
Offer a terse response. 3.58. What is the ratio of the Number of refugees in Hungary in 2007 to that in 2010?
Keep it short and to the point. 2.35. What is the ratio of the Number of refugees of Japan in 2007 to that in 2010?
Make the answer very short. 3.43. What is the ratio of the Number of refugees in Mexico in 2007 to that in 2010?
Offer a very short reply. 0.82. What is the ratio of the Number of refugees of West Bank and Gaza in 2007 to that in 2010?
Your answer should be compact. 3.66. What is the ratio of the Number of refugees of Hungary in 2007 to that in 2011?
Keep it short and to the point. 2.74. What is the ratio of the Number of refugees in Japan in 2007 to that in 2011?
Your response must be concise. 2.96. What is the ratio of the Number of refugees in Mexico in 2007 to that in 2011?
Your response must be concise. 0.75. What is the ratio of the Number of refugees of West Bank and Gaza in 2007 to that in 2011?
Provide a succinct answer. 3.62. What is the ratio of the Number of refugees of Hungary in 2007 to that in 2012?
Ensure brevity in your answer.  3.12. What is the ratio of the Number of refugees in Japan in 2007 to that in 2012?
Your answer should be very brief. 3.03. What is the ratio of the Number of refugees in Mexico in 2007 to that in 2012?
Provide a short and direct response. 0.66. What is the ratio of the Number of refugees of West Bank and Gaza in 2007 to that in 2012?
Offer a terse response. 3.6. What is the ratio of the Number of refugees of Hungary in 2008 to that in 2009?
Your answer should be compact. 1.05. What is the ratio of the Number of refugees in Japan in 2008 to that in 2009?
Offer a terse response. 1.23. What is the ratio of the Number of refugees of Mexico in 2008 to that in 2009?
Make the answer very short. 0.96. What is the ratio of the Number of refugees of West Bank and Gaza in 2008 to that in 2009?
Ensure brevity in your answer.  3.57. What is the ratio of the Number of refugees in Hungary in 2008 to that in 2010?
Provide a succinct answer. 1.12. What is the ratio of the Number of refugees of Japan in 2008 to that in 2010?
Provide a succinct answer. 1.22. What is the ratio of the Number of refugees in Mexico in 2008 to that in 2010?
Your response must be concise. 0.9. What is the ratio of the Number of refugees in West Bank and Gaza in 2008 to that in 2010?
Offer a terse response. 3.64. What is the ratio of the Number of refugees of Hungary in 2008 to that in 2011?
Your answer should be compact. 1.3. What is the ratio of the Number of refugees in Japan in 2008 to that in 2011?
Keep it short and to the point. 1.05. What is the ratio of the Number of refugees of Mexico in 2008 to that in 2011?
Your answer should be very brief. 0.82. What is the ratio of the Number of refugees in West Bank and Gaza in 2008 to that in 2011?
Provide a short and direct response. 3.61. What is the ratio of the Number of refugees of Hungary in 2008 to that in 2012?
Offer a terse response. 1.48. What is the ratio of the Number of refugees of Japan in 2008 to that in 2012?
Your answer should be very brief. 1.08. What is the ratio of the Number of refugees of Mexico in 2008 to that in 2012?
Make the answer very short. 0.73. What is the ratio of the Number of refugees of West Bank and Gaza in 2008 to that in 2012?
Give a very brief answer. 3.58. What is the ratio of the Number of refugees of Hungary in 2009 to that in 2010?
Ensure brevity in your answer.  1.07. What is the ratio of the Number of refugees in Japan in 2009 to that in 2010?
Offer a very short reply. 0.99. What is the ratio of the Number of refugees in Mexico in 2009 to that in 2010?
Your answer should be very brief. 0.94. What is the ratio of the Number of refugees of West Bank and Gaza in 2009 to that in 2010?
Give a very brief answer. 1.02. What is the ratio of the Number of refugees in Hungary in 2009 to that in 2011?
Provide a short and direct response. 1.24. What is the ratio of the Number of refugees in Japan in 2009 to that in 2011?
Keep it short and to the point. 0.85. What is the ratio of the Number of refugees of Mexico in 2009 to that in 2011?
Provide a succinct answer. 0.86. What is the ratio of the Number of refugees in West Bank and Gaza in 2009 to that in 2011?
Keep it short and to the point. 1.01. What is the ratio of the Number of refugees in Hungary in 2009 to that in 2012?
Your response must be concise. 1.41. What is the ratio of the Number of refugees of Japan in 2009 to that in 2012?
Offer a terse response. 0.87. What is the ratio of the Number of refugees of Mexico in 2009 to that in 2012?
Provide a succinct answer. 0.76. What is the ratio of the Number of refugees of West Bank and Gaza in 2009 to that in 2012?
Your answer should be compact. 1. What is the ratio of the Number of refugees of Hungary in 2010 to that in 2011?
Ensure brevity in your answer.  1.16. What is the ratio of the Number of refugees in Japan in 2010 to that in 2011?
Provide a succinct answer. 0.86. What is the ratio of the Number of refugees of Mexico in 2010 to that in 2011?
Offer a terse response. 0.91. What is the ratio of the Number of refugees of Hungary in 2010 to that in 2012?
Your answer should be very brief. 1.32. What is the ratio of the Number of refugees in Japan in 2010 to that in 2012?
Your response must be concise. 0.88. What is the ratio of the Number of refugees of Mexico in 2010 to that in 2012?
Your response must be concise. 0.81. What is the ratio of the Number of refugees in West Bank and Gaza in 2010 to that in 2012?
Offer a very short reply. 0.98. What is the ratio of the Number of refugees of Hungary in 2011 to that in 2012?
Your answer should be very brief. 1.14. What is the ratio of the Number of refugees of Japan in 2011 to that in 2012?
Your response must be concise. 1.02. What is the ratio of the Number of refugees of Mexico in 2011 to that in 2012?
Keep it short and to the point. 0.89. What is the ratio of the Number of refugees in West Bank and Gaza in 2011 to that in 2012?
Ensure brevity in your answer.  0.99. What is the difference between the highest and the second highest Number of refugees in Hungary?
Provide a succinct answer. 268. What is the difference between the highest and the second highest Number of refugees in Japan?
Provide a short and direct response. 336. What is the difference between the highest and the second highest Number of refugees of Mexico?
Your answer should be compact. 963. What is the difference between the highest and the second highest Number of refugees in West Bank and Gaza?
Provide a succinct answer. 1221. What is the difference between the highest and the lowest Number of refugees of Hungary?
Ensure brevity in your answer.  2299. What is the difference between the highest and the lowest Number of refugees of Japan?
Make the answer very short. 371. What is the difference between the highest and the lowest Number of refugees of Mexico?
Your response must be concise. 5131. What is the difference between the highest and the lowest Number of refugees in West Bank and Gaza?
Your answer should be very brief. 2.48e+05. 